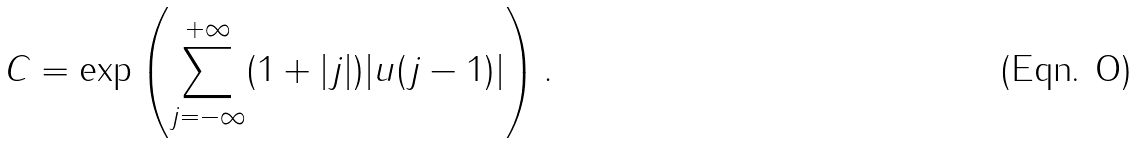Convert formula to latex. <formula><loc_0><loc_0><loc_500><loc_500>C = \exp \left ( \sum _ { j = - \infty } ^ { + \infty } ( 1 + | j | ) | u ( j - 1 ) | \right ) .</formula> 